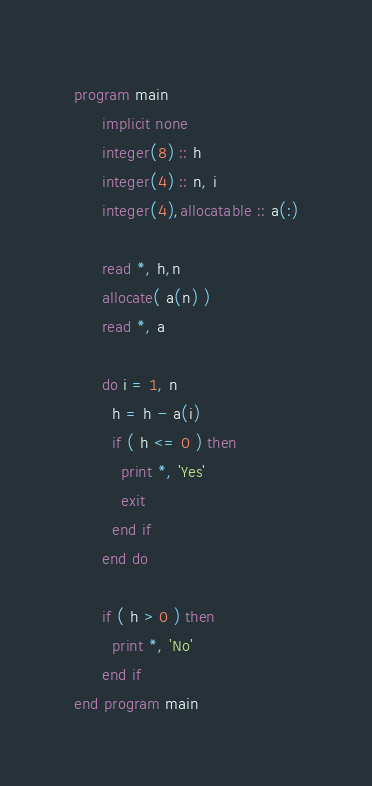Convert code to text. <code><loc_0><loc_0><loc_500><loc_500><_FORTRAN_>program main
      implicit none
      integer(8) :: h
      integer(4) :: n, i
      integer(4),allocatable :: a(:)

      read *, h,n
      allocate( a(n) )
      read *, a

      do i = 1, n
        h = h - a(i)
        if ( h <= 0 ) then
          print *, 'Yes'
          exit
        end if
      end do

      if ( h > 0 ) then
        print *, 'No'
      end if
end program main
</code> 